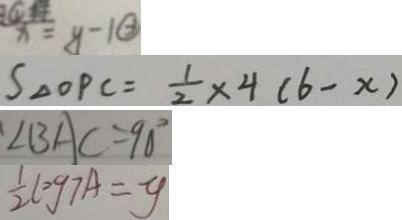<formula> <loc_0><loc_0><loc_500><loc_500>x = y - 1 \textcircled { 2 } 
 S _ { \Delta O P C } = \frac { 1 } { 2 } \times 4 ( 6 - x ) 
 \angle B A C = 9 0 ^ { \circ } 
 \frac { 1 } { 2 } \log 7 A = y</formula> 